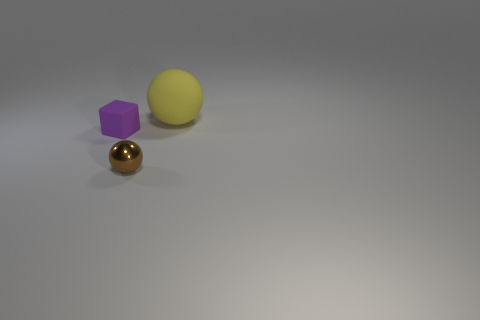Are there any other things that are the same size as the yellow rubber ball?
Your answer should be very brief. No. What material is the other thing that is the same shape as the brown shiny thing?
Your response must be concise. Rubber. Is there any other thing that has the same material as the small brown object?
Offer a very short reply. No. What shape is the other thing that is the same material as the large object?
Ensure brevity in your answer.  Cube. What number of other big objects have the same shape as the shiny object?
Make the answer very short. 1. What shape is the rubber object that is left of the thing behind the tiny purple rubber thing?
Give a very brief answer. Cube. Do the rubber thing behind the purple thing and the tiny brown shiny ball have the same size?
Provide a succinct answer. No. What is the size of the object that is behind the tiny brown shiny object and right of the tiny purple rubber object?
Make the answer very short. Large. What number of other yellow balls have the same size as the metal ball?
Your answer should be compact. 0. What number of tiny objects are in front of the tiny object behind the small sphere?
Your answer should be compact. 1. 